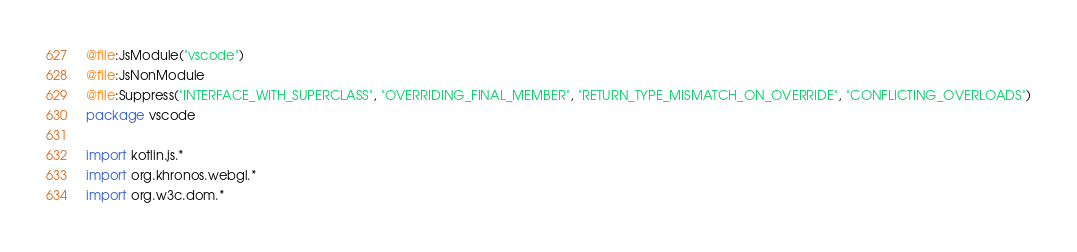Convert code to text. <code><loc_0><loc_0><loc_500><loc_500><_Kotlin_>@file:JsModule("vscode")
@file:JsNonModule
@file:Suppress("INTERFACE_WITH_SUPERCLASS", "OVERRIDING_FINAL_MEMBER", "RETURN_TYPE_MISMATCH_ON_OVERRIDE", "CONFLICTING_OVERLOADS")
package vscode

import kotlin.js.*
import org.khronos.webgl.*
import org.w3c.dom.*</code> 